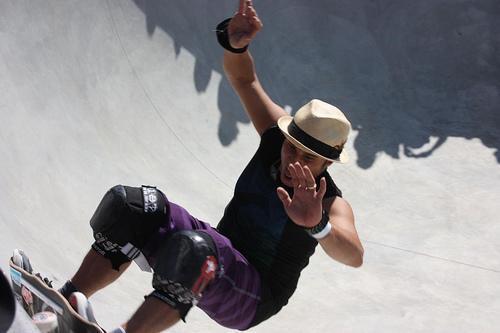How many people are skateboarding?
Give a very brief answer. 1. How many people are pictured here?
Give a very brief answer. 1. How many birds are in the sky?
Give a very brief answer. 0. 